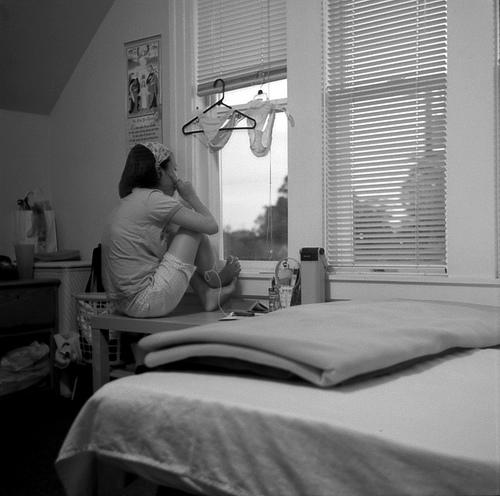Why are the underpants hanging there? to dry 